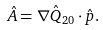<formula> <loc_0><loc_0><loc_500><loc_500>\hat { A } = { \nabla } \hat { Q } _ { 2 0 } \cdot \hat { p } .</formula> 